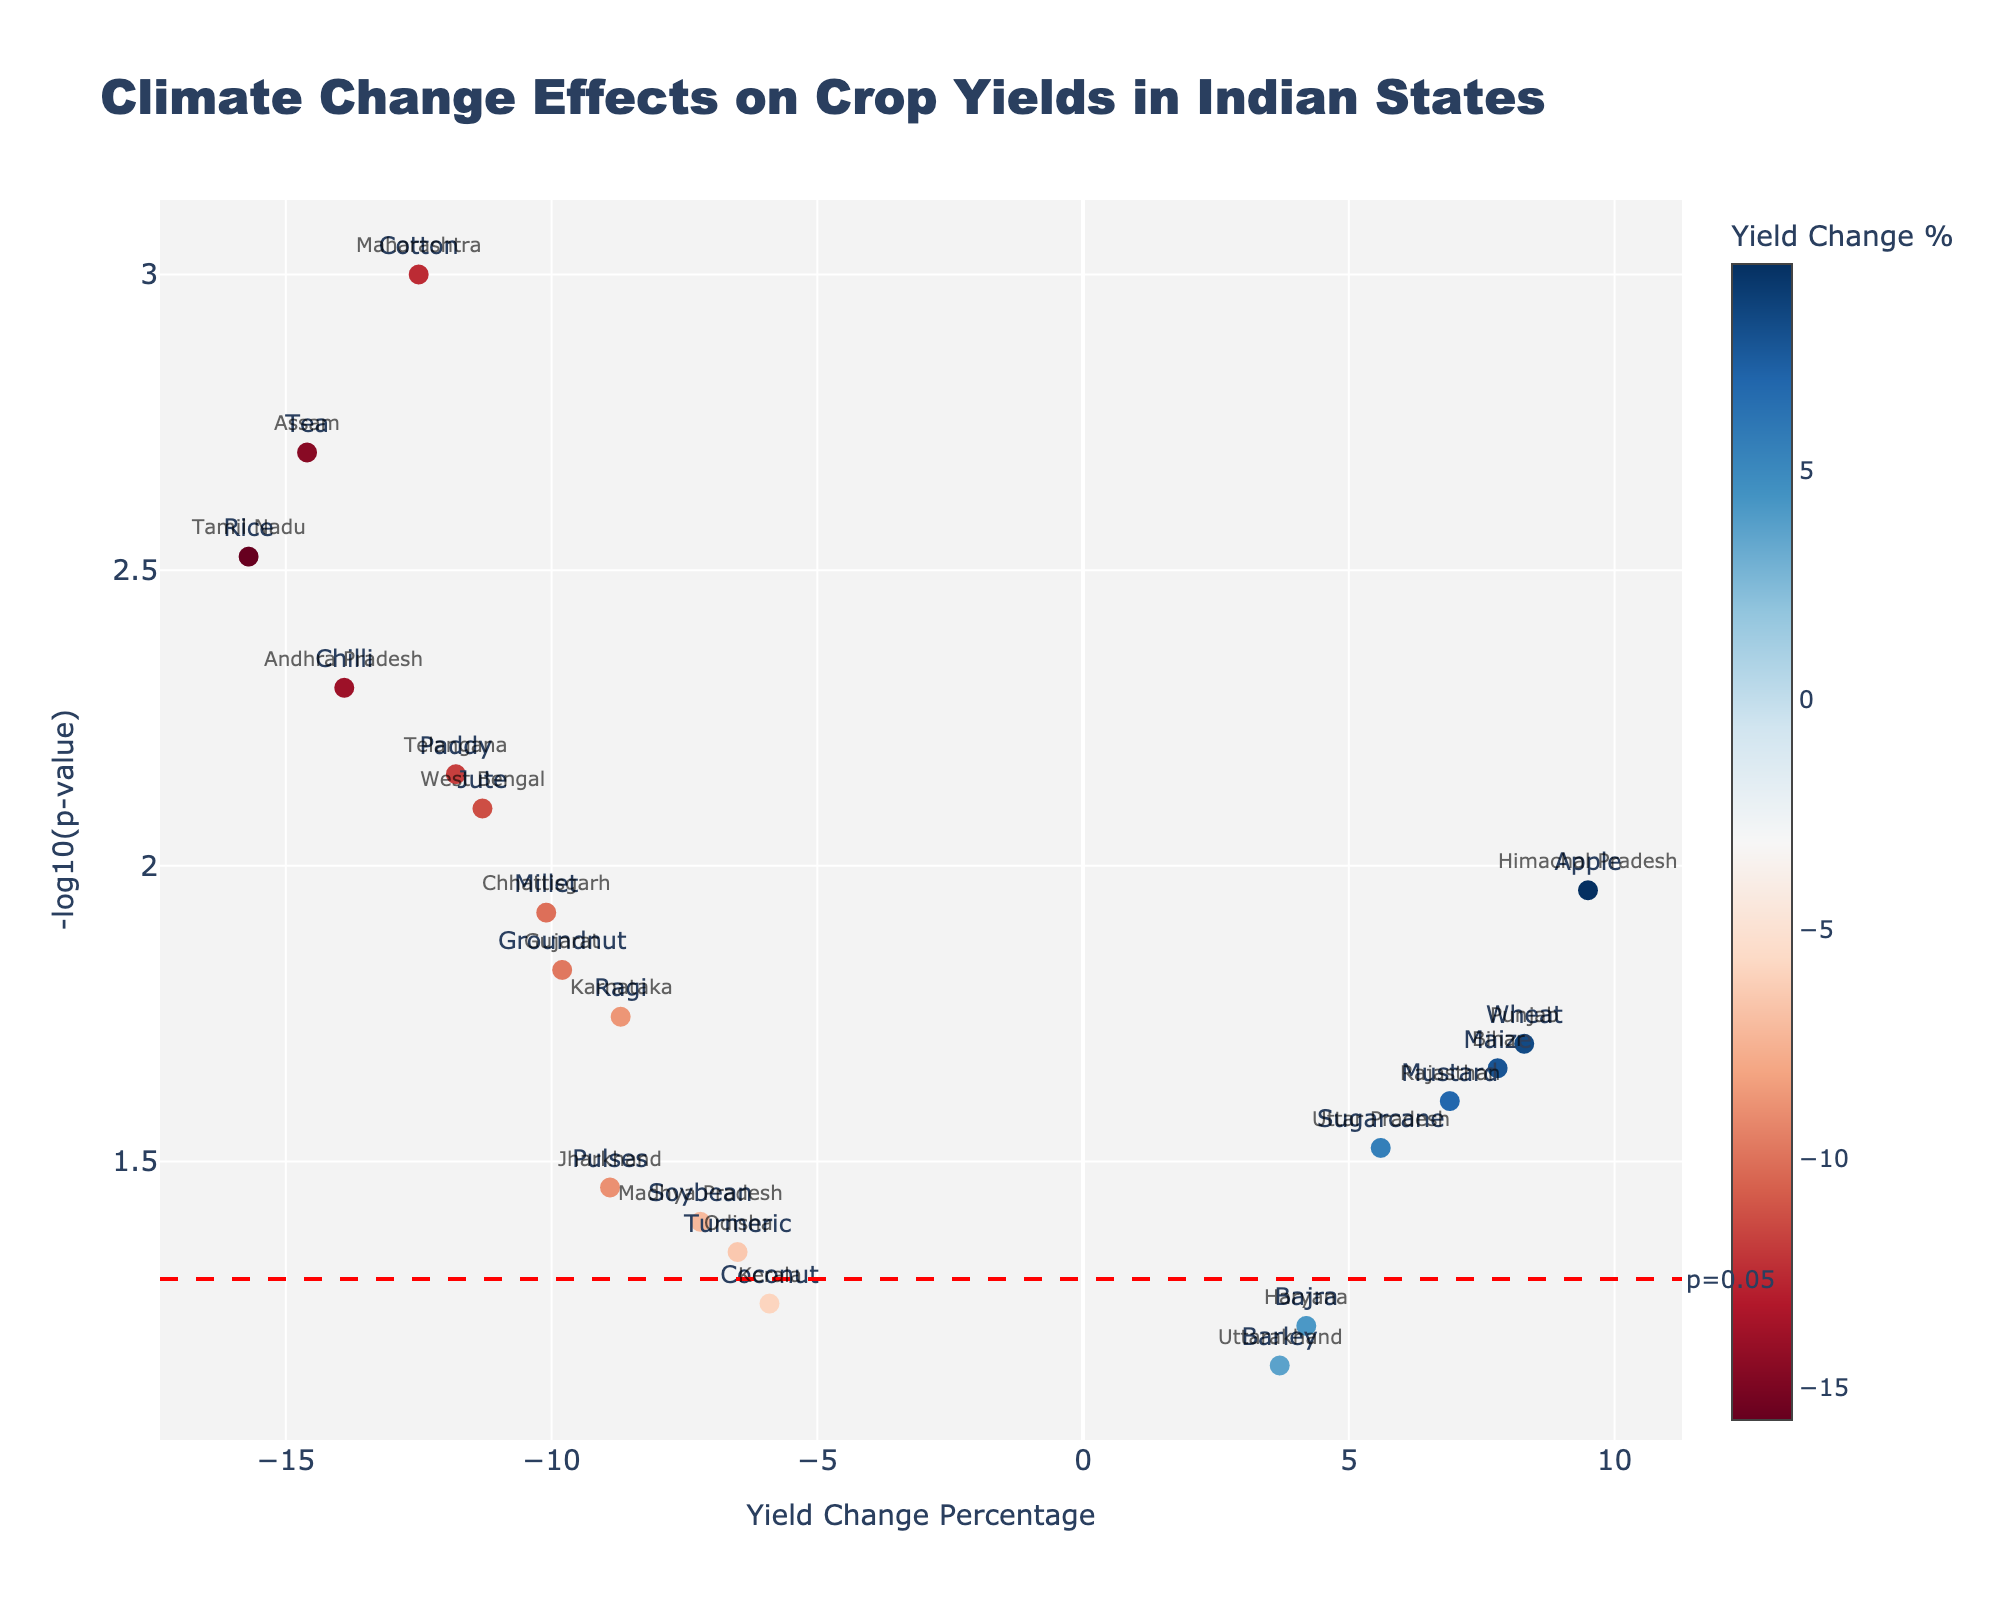How many crop yield changes are less than zero? There are crop markers below the x-axis. Counting them, we get: Cotton, Rice, Groundnut, Soybean, Jute, Ragi, Chilli, Turmeric, Coconut, Tea, Pulses, Paddy.
Answer: 12 What's the highest yield change percentage observed? The marker with the highest x-value, representing yield change percentage, corresponds to Apple in Himachal Pradesh with a 9.5% yield increase.
Answer: 9.5% Which crop has the most significant p-value? The marker with the highest y-value, representing -log10(p-value), corresponds to Cotton in Maharashtra with a p-value of 0.001.
Answer: Cotton What is the average yield change percentage for crops with significant p-values (p < 0.05)? List the crops with significant p-values: Cotton, Rice, Groundnut, Soybean, Sugarcane, Jute, Mustard, Ragi, Chilli, Maize, Millet, Tea, Apple, Pulses, Paddy. Calculate their average yield: (-12.5 - 15.7 - 9.8 - 7.2 + 5.6 - 11.3 + 6.9 - 8.7 - 13.9 + 7.8 - 10.1 - 14.6 + 9.5 - 8.9 - 11.8)/15 = -5.11%.
Answer: -5.11% Which state has the smallest negative yield change percentage? The data point closest to zero on the negative side of the x-axis is Kerala with a Coconut yield change of -5.9%.
Answer: Kerala (Coconut) How many crops have a positive yield change? There are crop markers to the right of the y-axis. Counting them, we get: Wheat, Sugarcane, Mustard, Bajra, Maize, Apple, Barley.
Answer: 7 Which crop has the least significant p-value? The marker with the lowest y-value, representing -log10(p-value), corresponds to Barley in Uttarakhand with a p-value of 0.07.
Answer: Barley What's the average -log10(p-value) for crops with positive yield changes? List the crops with positive yield changes: Wheat, Sugarcane, Mustard, Bajra, Maize, Apple, Barley. Calculate their average -log10(p-value): -(log10(0.02) + log10(0.03) + log10(0.025) + log10(0.06) + log10(0.022) + log10(0.011) + log10(0.07))/7 = 1.58.
Answer: 1.58 Which states have crops with yield changes greater than 5%? The data points with x-values greater than 5% correspond to: Punjab (Wheat), Uttar Pradesh (Sugarcane), Rajasthan (Mustard), Himachal Pradesh (Apple), Bihar (Maize).
Answer: Punjab, Uttar Pradesh, Rajasthan, Himachal Pradesh, Bihar What is the range of yield changes observed for states in Southern India? Southern states (Tamil Nadu, Karnataka, Andhra Pradesh, Kerala, Telangana) have these yield changes: Rice (-15.7), Ragi (-8.7), Chilli (-13.9), Coconut (-5.9), Paddy (-11.8). The range is the difference between highest and lowest: -5.9 - (-15.7) = 9.8%.
Answer: 9.8% 